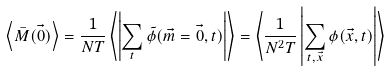<formula> <loc_0><loc_0><loc_500><loc_500>\left \langle \bar { M } ( \vec { 0 } ) \right \rangle = \frac { 1 } { N T } \left \langle \left | \sum _ { t } \tilde { \phi } ( \vec { m } = \vec { 0 } , t ) \right | \right \rangle = \left \langle \frac { 1 } { N ^ { 2 } T } \left | \sum _ { t , \vec { x } } \phi ( \vec { x } , t ) \right | \right \rangle</formula> 